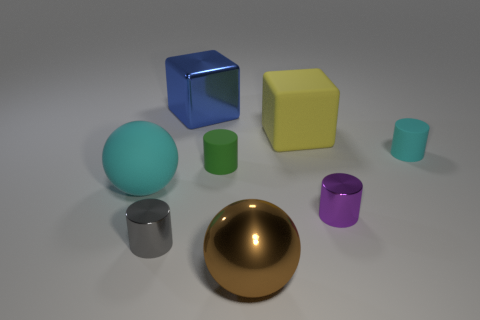Describe the relative sizes of the objects in the image. There is a large blue cube, a medium-sized yellow cube, and a small purple cube, as well as large and small spheres and cylinders. The largest object is the golden hemisphere, while the smallest ones are the tiny cylinder and sphere at the front. 